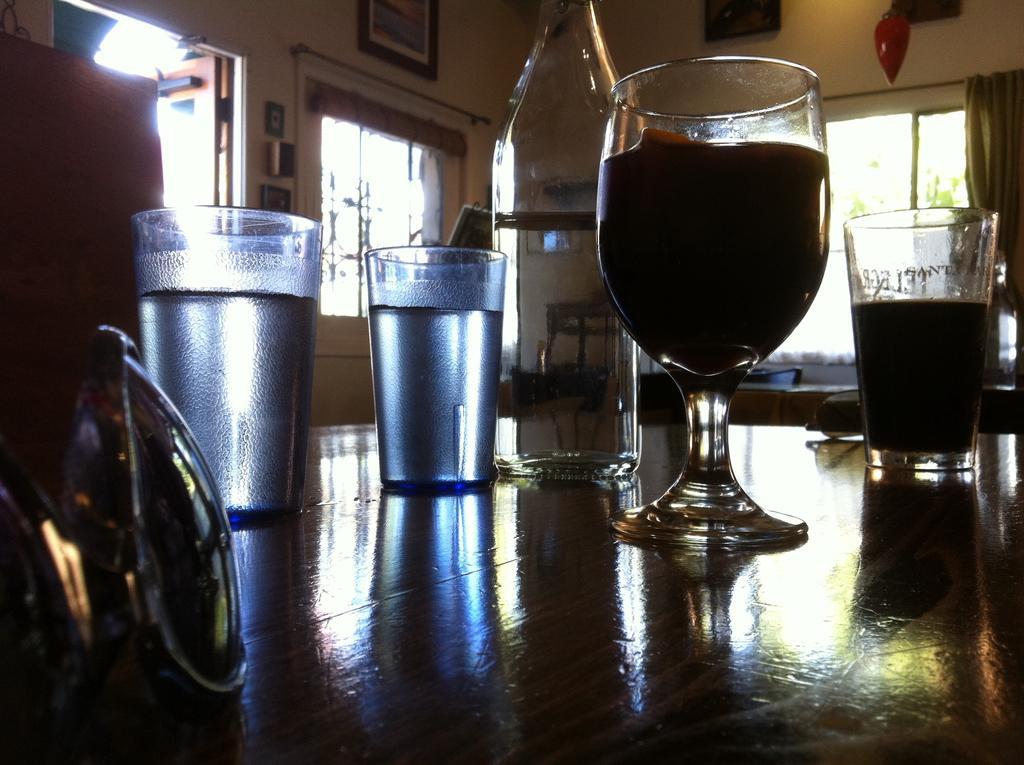Describe this image in one or two sentences. in this image the 3 glasses and one wine glass is there on the table the table is inside the room the room has some photos,windows and something else. 